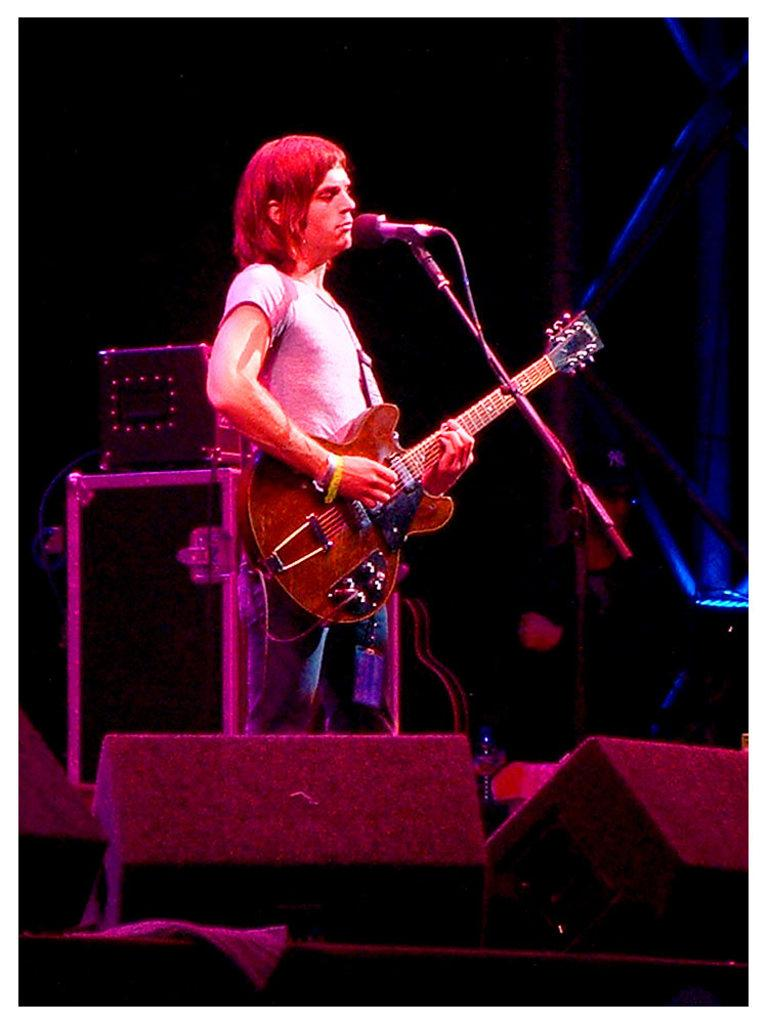Who is the main subject in the image? There is a man in the image. Where is the man located in the image? The man is standing on a stage. What is the man holding in the image? The man is holding a guitar. What is the man doing with the guitar? The man is playing the guitar. What equipment is present near the man? The man is in front of a microphone and stand. What can be seen in the background of the image? There are speakers and a light in the background of the image. What type of note is the man singing in the image? There is no indication in the image that the man is singing, and therefore no such activity can be observed. 